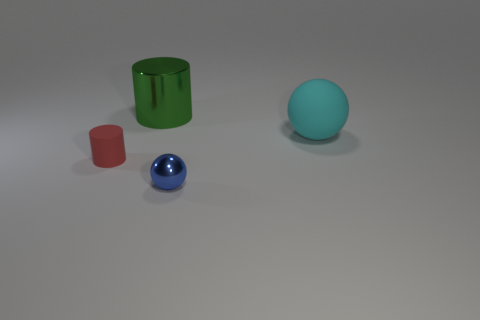Add 3 tiny purple shiny cylinders. How many objects exist? 7 Add 2 large blue shiny cylinders. How many large blue shiny cylinders exist? 2 Subtract 1 blue balls. How many objects are left? 3 Subtract all shiny cylinders. Subtract all cyan rubber things. How many objects are left? 2 Add 1 tiny things. How many tiny things are left? 3 